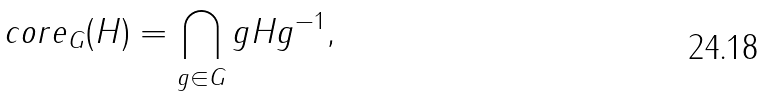Convert formula to latex. <formula><loc_0><loc_0><loc_500><loc_500>c o r e _ { G } ( H ) = \bigcap _ { g \in G } g H g ^ { - 1 } ,</formula> 